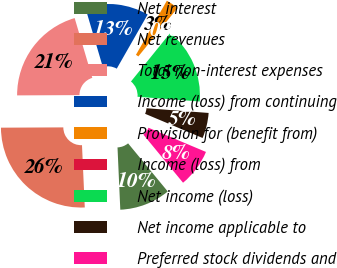Convert chart to OTSL. <chart><loc_0><loc_0><loc_500><loc_500><pie_chart><fcel>Net interest<fcel>Net revenues<fcel>Total non-interest expenses<fcel>Income (loss) from continuing<fcel>Provision for (benefit from)<fcel>Income (loss) from<fcel>Net income (loss)<fcel>Net income applicable to<fcel>Preferred stock dividends and<nl><fcel>10.26%<fcel>25.64%<fcel>20.51%<fcel>12.82%<fcel>2.57%<fcel>0.0%<fcel>15.38%<fcel>5.13%<fcel>7.69%<nl></chart> 